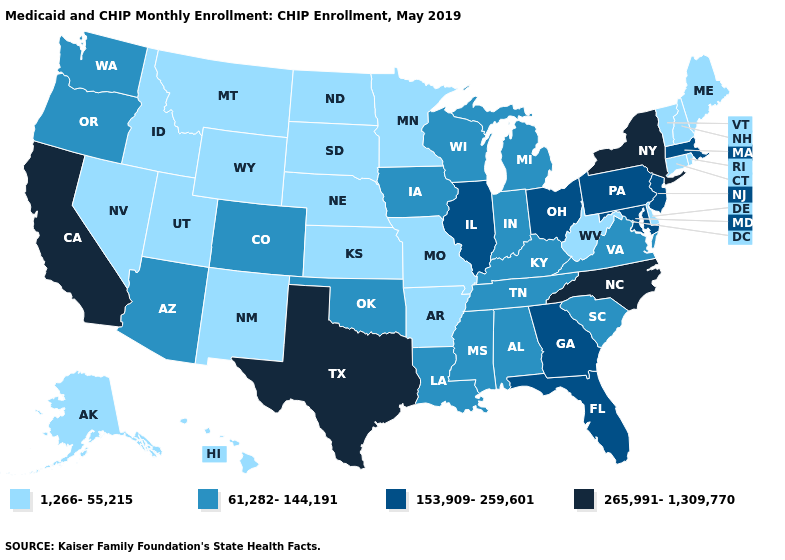What is the highest value in states that border Texas?
Give a very brief answer. 61,282-144,191. What is the value of Oregon?
Be succinct. 61,282-144,191. Which states have the lowest value in the USA?
Be succinct. Alaska, Arkansas, Connecticut, Delaware, Hawaii, Idaho, Kansas, Maine, Minnesota, Missouri, Montana, Nebraska, Nevada, New Hampshire, New Mexico, North Dakota, Rhode Island, South Dakota, Utah, Vermont, West Virginia, Wyoming. What is the value of Alaska?
Give a very brief answer. 1,266-55,215. Does South Dakota have a lower value than Alaska?
Concise answer only. No. What is the highest value in the MidWest ?
Write a very short answer. 153,909-259,601. What is the value of Virginia?
Concise answer only. 61,282-144,191. What is the highest value in the West ?
Short answer required. 265,991-1,309,770. Does the map have missing data?
Quick response, please. No. What is the value of California?
Be succinct. 265,991-1,309,770. Does Rhode Island have the highest value in the Northeast?
Be succinct. No. What is the value of New Mexico?
Be succinct. 1,266-55,215. Name the states that have a value in the range 153,909-259,601?
Short answer required. Florida, Georgia, Illinois, Maryland, Massachusetts, New Jersey, Ohio, Pennsylvania. Which states have the highest value in the USA?
Quick response, please. California, New York, North Carolina, Texas. What is the lowest value in the Northeast?
Short answer required. 1,266-55,215. 